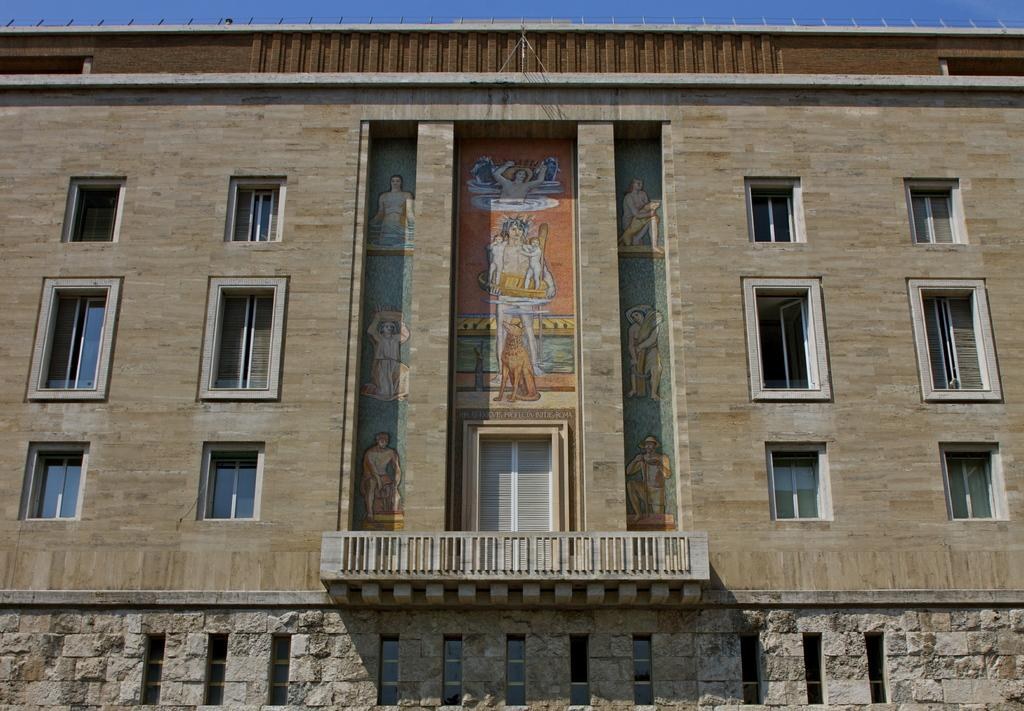What type of structure is visible in the image? There is a building in the image. What feature can be seen on the building's exterior? The building has glass windows. Is there any safety feature present on the building? Yes, the building has a railing. How can one enter the building? The building has a door. What decorative elements are present inside the building? There are pictures on the wall. What is the color of the sky in the image? The sky is blue in color. Where is the tray located in the image? There is no tray present in the image. What shape is the sea in the image? There is no sea present in the image. 